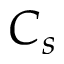Convert formula to latex. <formula><loc_0><loc_0><loc_500><loc_500>C _ { s }</formula> 